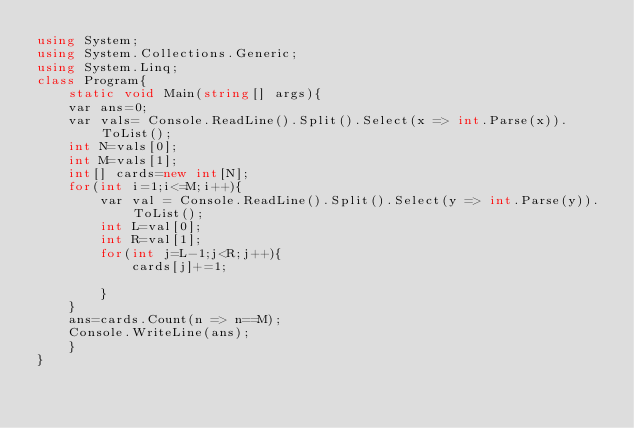<code> <loc_0><loc_0><loc_500><loc_500><_C#_>using System;
using System.Collections.Generic;
using System.Linq;
class Program{
    static void Main(string[] args){
    var ans=0;
    var vals= Console.ReadLine().Split().Select(x => int.Parse(x)).ToList();
    int N=vals[0];
    int M=vals[1];
    int[] cards=new int[N];
    for(int i=1;i<=M;i++){
        var val = Console.ReadLine().Split().Select(y => int.Parse(y)).ToList();
        int L=val[0];
        int R=val[1];
        for(int j=L-1;j<R;j++){
            cards[j]+=1;
          
        }
    }
    ans=cards.Count(n => n==M);
    Console.WriteLine(ans);
    }
}</code> 